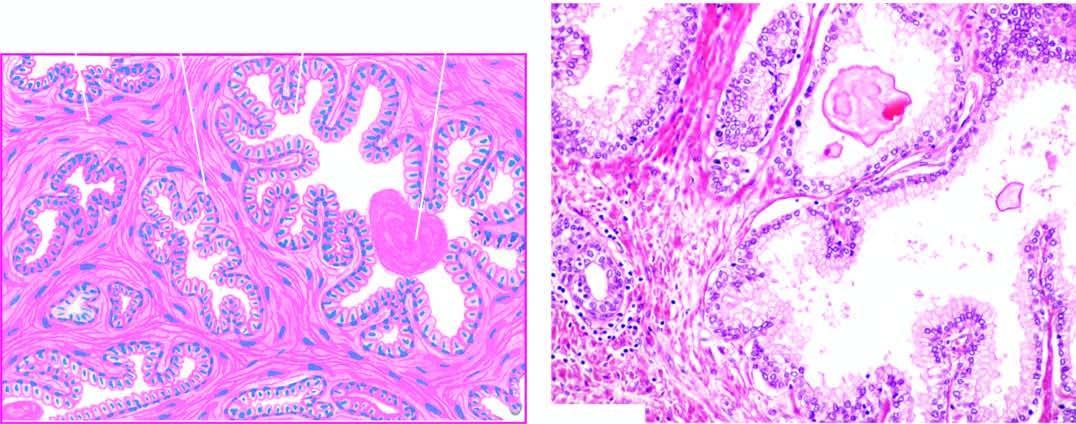how many layers are there?
Answer the question using a single word or phrase. Two 